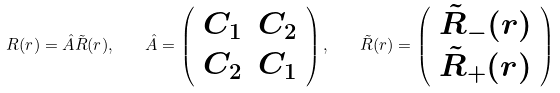<formula> <loc_0><loc_0><loc_500><loc_500>R ( r ) = \hat { A } \tilde { R } ( r ) , \quad \hat { A } = \left ( \begin{array} { c c } C _ { 1 } & C _ { 2 } \\ C _ { 2 } & C _ { 1 } \end{array} \right ) , \quad \tilde { R } ( r ) = \left ( \begin{array} { c c } \tilde { R } _ { - } ( r ) \\ \tilde { R } _ { + } ( r ) \end{array} \right )</formula> 